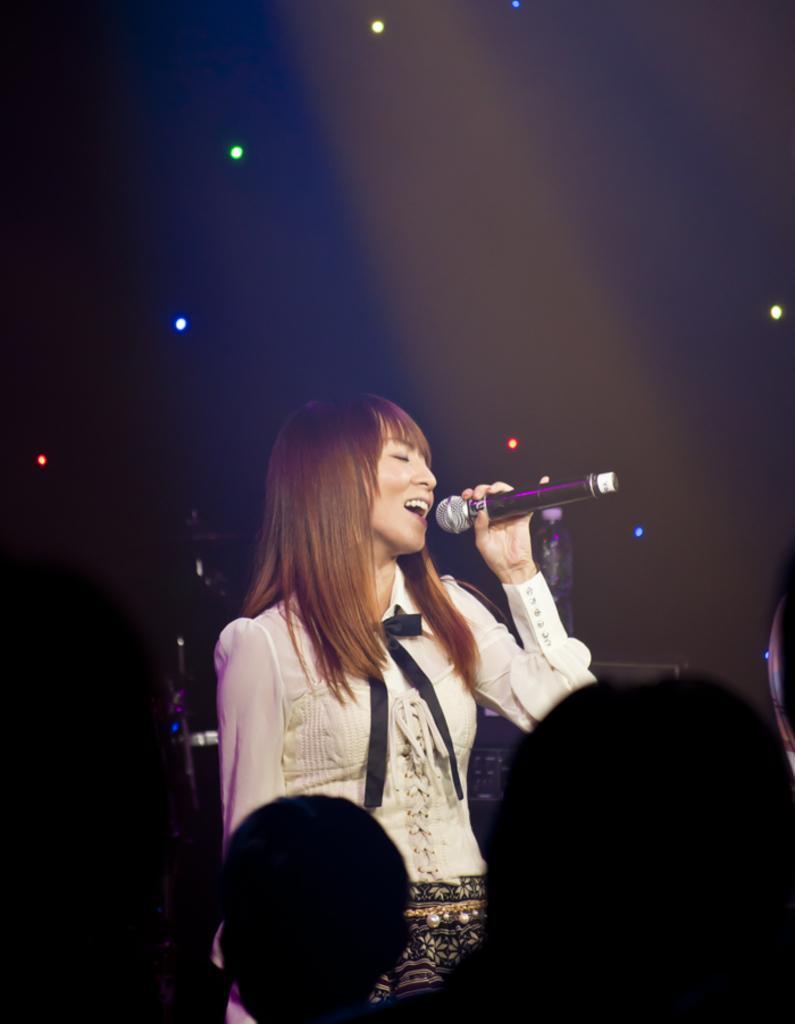In one or two sentences, can you explain what this image depicts? In this image, In the middle there is a girl she is standing and she is holding a microphone which is in black color and she is singing in the microphone. 